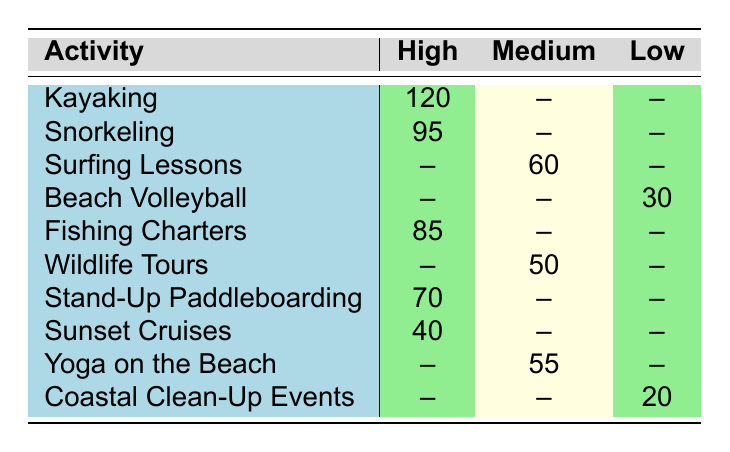What is the highest guest satisfaction rating category in the table? The table contains three guest satisfaction categories: High, Medium, and Low. Among these, High is listed as the highest category, as it indicates better guest satisfaction compared to the other two.
Answer: High How many guests rated Yoga on the Beach with Medium satisfaction? The table specifies that Yoga on the Beach received a Medium satisfaction rating and has a count of 55 guests. This is a direct retrieval of the value from the table.
Answer: 55 Which coastal activity had the lowest guest satisfaction rating and what was the count? The table indicates that Beach Volleyball and Coastal Clean-Up Events were rated as Low. Checking the count for Beach Volleyball gives 30 guests, while Coastal Clean-Up Events had 20 guests. Therefore, Coastal Clean-Up Events had the lowest rating and a count of 20.
Answer: Coastal Clean-Up Events, 20 What is the total count of guests who rated snorkeling and fishing charters with High satisfaction? The count for snorkeling with High satisfaction is 95 and for fishing charters, it is 85. To find the total, sum these counts: 95 + 85 = 180.
Answer: 180 Are there any coastal activities that received a Medium rating with more guests than those who rated Beach Volleyball? Beach Volleyball received a Low rating with a count of 30. The activities with Medium ratings are Surfing Lessons (60 guests), Wildlife Tours (50 guests), and Yoga on the Beach (55 guests). All these counts exceed 30, confirming that there are activities with Medium ratings that have more guests.
Answer: Yes What is the average number of guest satisfaction ratings for activities categorized as High? The counts for activities rated High are 120 (Kayaking), 95 (Snorkeling), 85 (Fishing Charters), 70 (Stand-Up Paddleboarding), and 40 (Sunset Cruises). To find the average, add these together: 120 + 95 + 85 + 70 + 40 = 410. Since there are 5 activities, divide by 5: 410 / 5 = 82.
Answer: 82 Is the count of guests who rated Surfing Lessons as Medium greater than the count for Coastal Clean-Up Events? Surfing Lessons received a Medium rating with 60 guests, while Coastal Clean-Up Events received a Low rating with only 20 guests. Since 60 is greater than 20, this statement is true.
Answer: Yes Which coastal activity had a greater count than the average for High ratings? The average for High ratings is 82, as previously calculated. The activities that exceed this count are Kayaking (120), Snorkeling (95), and Fishing Charters (85). These three activities have counts greater than 82.
Answer: Kayaking, Snorkeling, Fishing Charters 